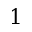Convert formula to latex. <formula><loc_0><loc_0><loc_500><loc_500>1</formula> 